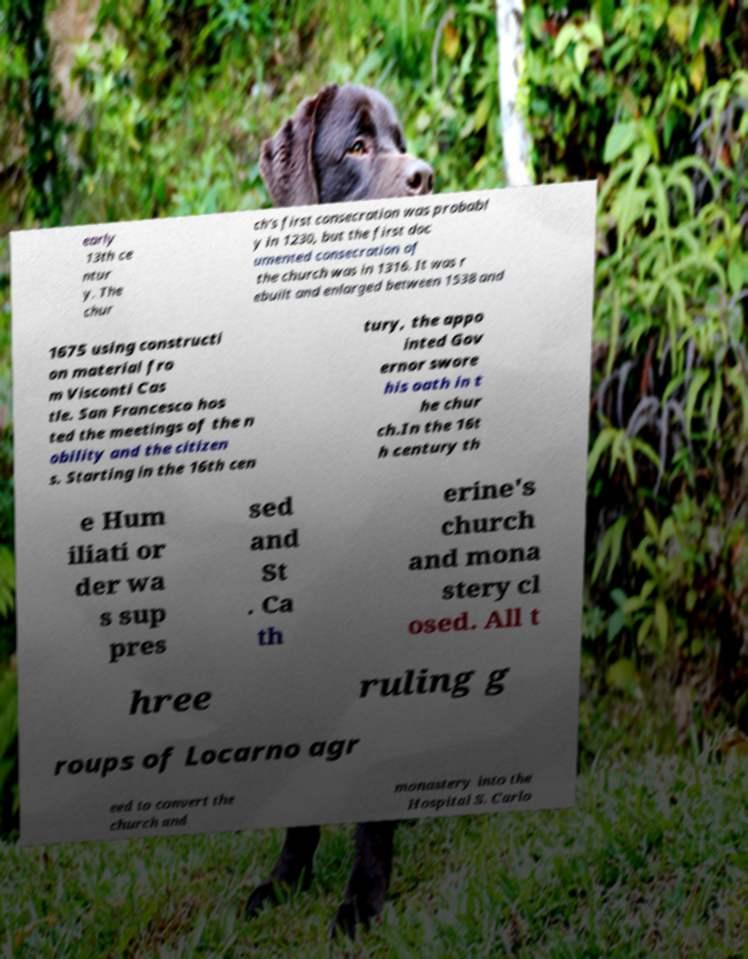What messages or text are displayed in this image? I need them in a readable, typed format. early 13th ce ntur y. The chur ch's first consecration was probabl y in 1230, but the first doc umented consecration of the church was in 1316. It was r ebuilt and enlarged between 1538 and 1675 using constructi on material fro m Visconti Cas tle. San Francesco hos ted the meetings of the n obility and the citizen s. Starting in the 16th cen tury, the appo inted Gov ernor swore his oath in t he chur ch.In the 16t h century th e Hum iliati or der wa s sup pres sed and St . Ca th erine's church and mona stery cl osed. All t hree ruling g roups of Locarno agr eed to convert the church and monastery into the Hospital S. Carlo 